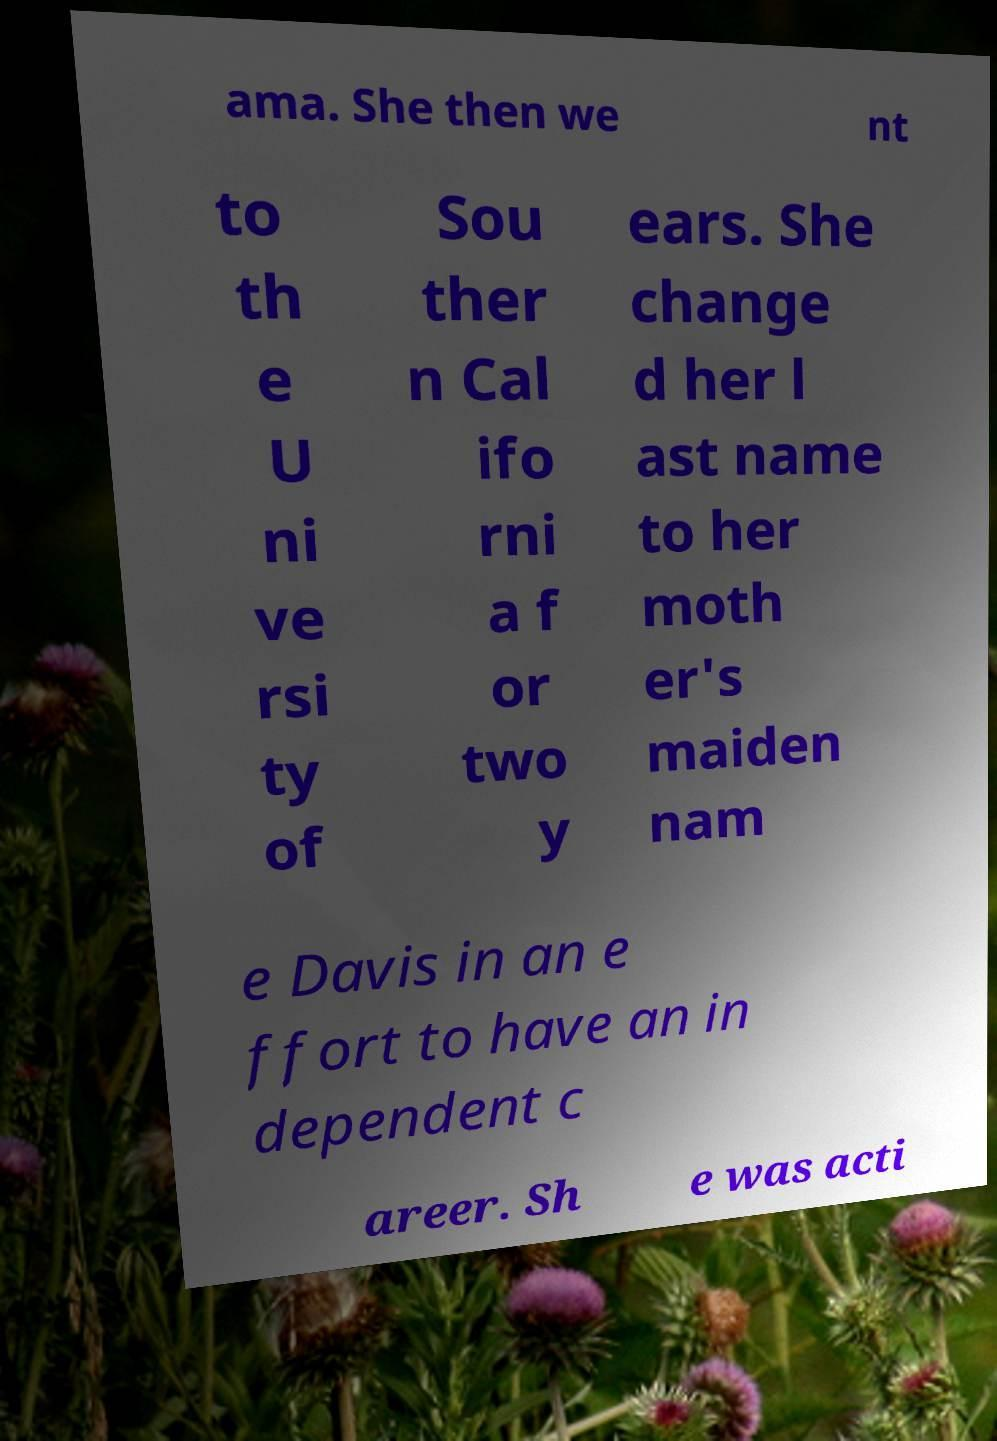I need the written content from this picture converted into text. Can you do that? ama. She then we nt to th e U ni ve rsi ty of Sou ther n Cal ifo rni a f or two y ears. She change d her l ast name to her moth er's maiden nam e Davis in an e ffort to have an in dependent c areer. Sh e was acti 